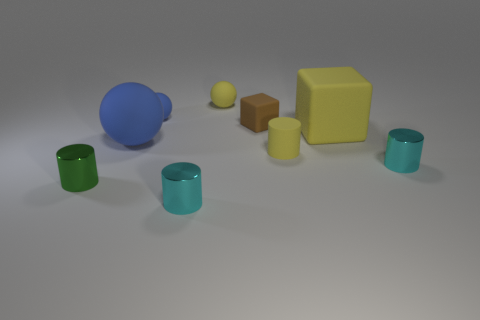There is a cyan metal object on the left side of the cyan object right of the tiny yellow matte cylinder; how big is it?
Your answer should be very brief. Small. How many small things are spheres or rubber blocks?
Keep it short and to the point. 3. There is a thing that is in front of the metal cylinder that is to the left of the big thing that is to the left of the brown object; what is its size?
Make the answer very short. Small. Are there any other things of the same color as the tiny rubber cube?
Make the answer very short. No. What is the brown block right of the small cyan cylinder that is to the left of the large matte object to the right of the tiny yellow sphere made of?
Ensure brevity in your answer.  Rubber. Do the tiny blue object and the large blue object have the same shape?
Make the answer very short. Yes. How many things are both behind the large matte ball and left of the big cube?
Offer a terse response. 3. There is a matte ball that is right of the cyan metallic thing that is to the left of the yellow sphere; what is its color?
Make the answer very short. Yellow. Are there an equal number of tiny metallic things to the left of the big yellow cube and tiny balls?
Your response must be concise. Yes. There is a blue object right of the blue matte thing that is in front of the brown matte cube; what number of small green shiny objects are behind it?
Provide a short and direct response. 0. 